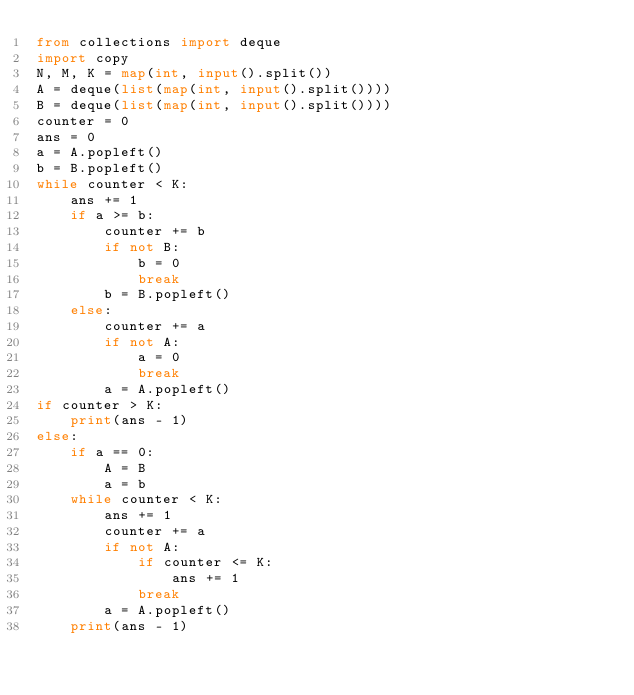Convert code to text. <code><loc_0><loc_0><loc_500><loc_500><_Python_>from collections import deque
import copy
N, M, K = map(int, input().split())
A = deque(list(map(int, input().split())))
B = deque(list(map(int, input().split())))
counter = 0
ans = 0
a = A.popleft()
b = B.popleft()
while counter < K:
    ans += 1
    if a >= b:
        counter += b
        if not B:
            b = 0
            break
        b = B.popleft()
    else:
        counter += a
        if not A:
            a = 0
            break
        a = A.popleft()
if counter > K:
    print(ans - 1)
else:
    if a == 0:
        A = B
        a = b
    while counter < K:
        ans += 1
        counter += a
        if not A:
            if counter <= K:
                ans += 1
            break
        a = A.popleft()
    print(ans - 1)
    </code> 